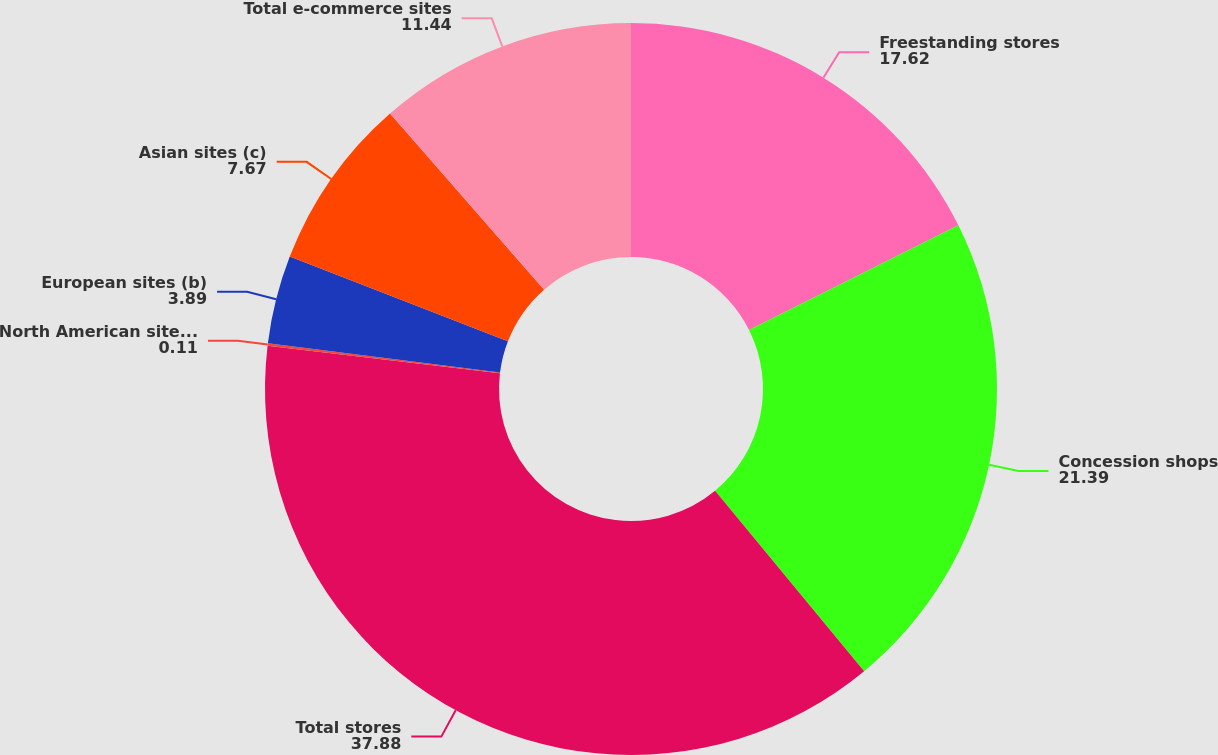<chart> <loc_0><loc_0><loc_500><loc_500><pie_chart><fcel>Freestanding stores<fcel>Concession shops<fcel>Total stores<fcel>North American sites (a)<fcel>European sites (b)<fcel>Asian sites (c)<fcel>Total e-commerce sites<nl><fcel>17.62%<fcel>21.39%<fcel>37.88%<fcel>0.11%<fcel>3.89%<fcel>7.67%<fcel>11.44%<nl></chart> 